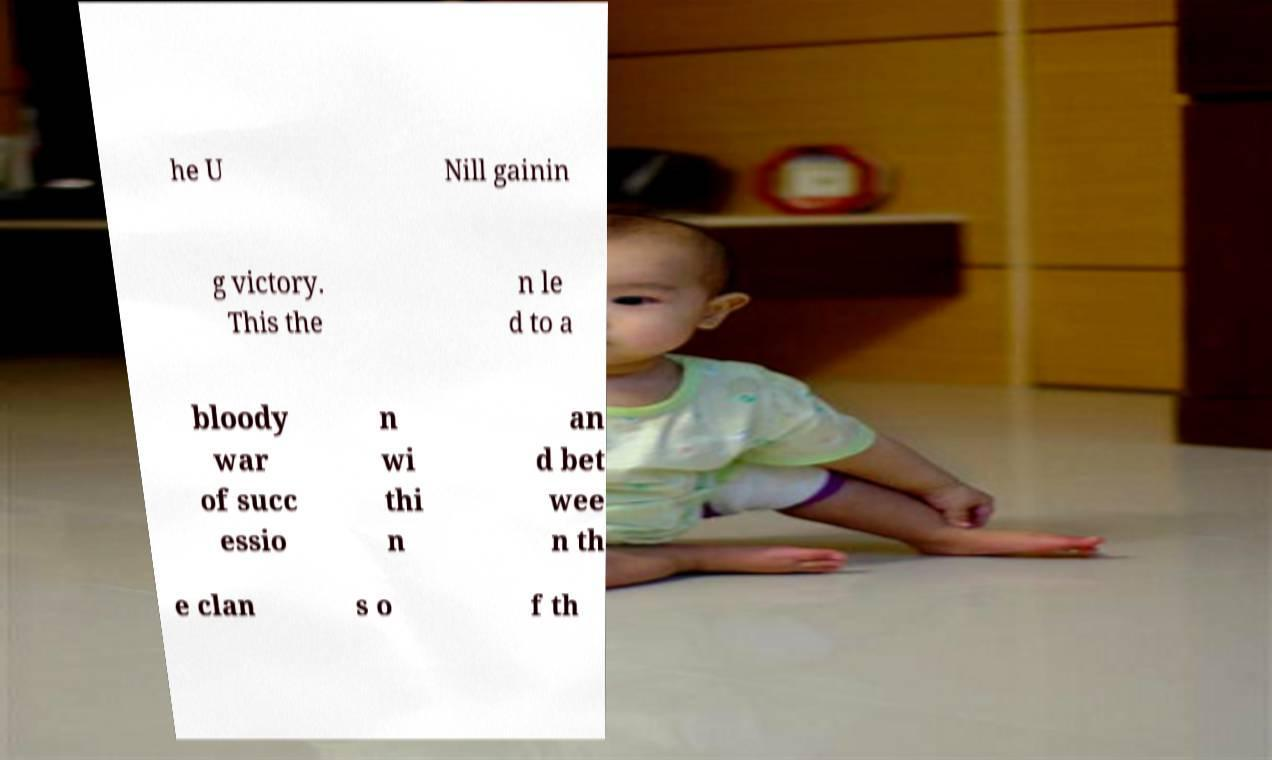Could you extract and type out the text from this image? he U Nill gainin g victory. This the n le d to a bloody war of succ essio n wi thi n an d bet wee n th e clan s o f th 